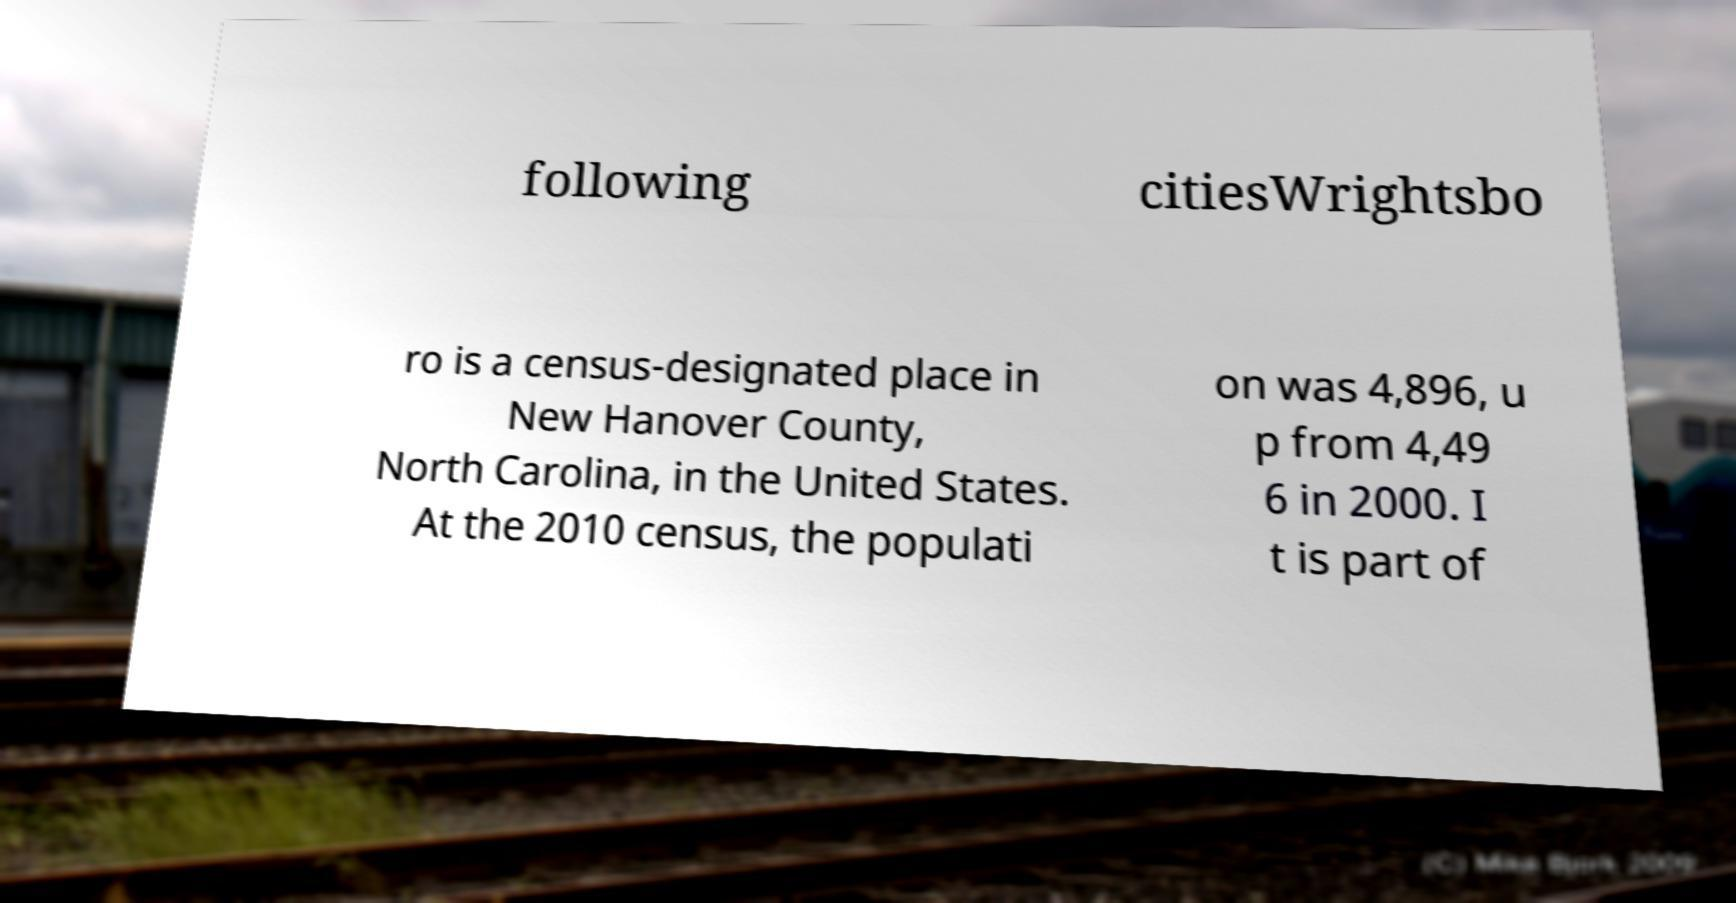There's text embedded in this image that I need extracted. Can you transcribe it verbatim? following citiesWrightsbo ro is a census-designated place in New Hanover County, North Carolina, in the United States. At the 2010 census, the populati on was 4,896, u p from 4,49 6 in 2000. I t is part of 